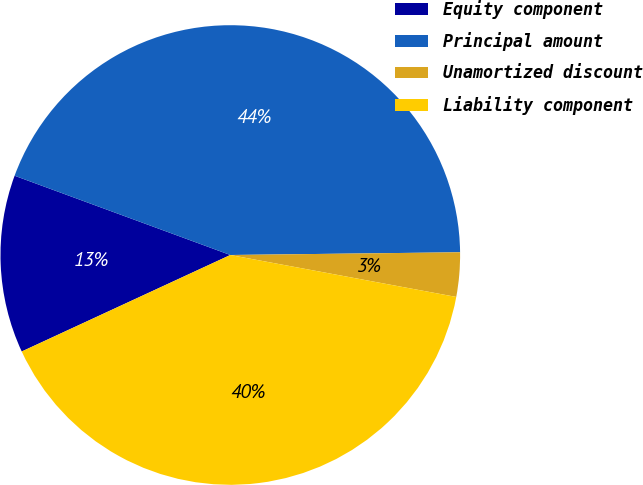Convert chart. <chart><loc_0><loc_0><loc_500><loc_500><pie_chart><fcel>Equity component<fcel>Principal amount<fcel>Unamortized discount<fcel>Liability component<nl><fcel>12.5%<fcel>44.2%<fcel>3.11%<fcel>40.18%<nl></chart> 